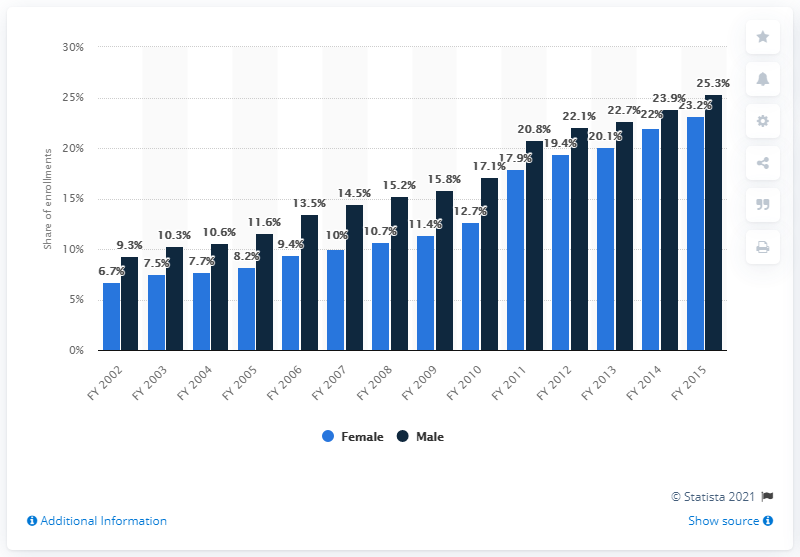Indicate a few pertinent items in this graphic. In the financial year 2015, approximately 23.2% of females in India were enrolled in higher education. 